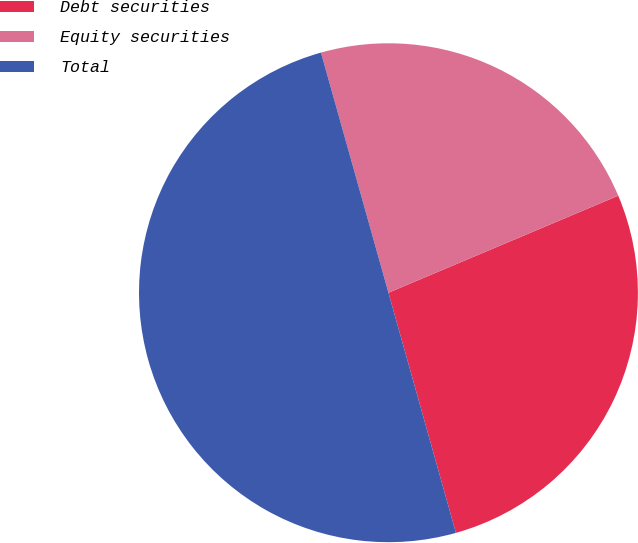<chart> <loc_0><loc_0><loc_500><loc_500><pie_chart><fcel>Debt securities<fcel>Equity securities<fcel>Total<nl><fcel>27.0%<fcel>23.0%<fcel>50.0%<nl></chart> 